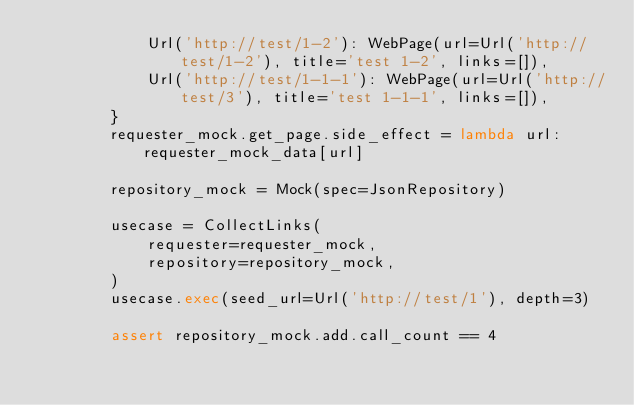Convert code to text. <code><loc_0><loc_0><loc_500><loc_500><_Python_>            Url('http://test/1-2'): WebPage(url=Url('http://test/1-2'), title='test 1-2', links=[]),
            Url('http://test/1-1-1'): WebPage(url=Url('http://test/3'), title='test 1-1-1', links=[]),
        }
        requester_mock.get_page.side_effect = lambda url: requester_mock_data[url]

        repository_mock = Mock(spec=JsonRepository)

        usecase = CollectLinks(
            requester=requester_mock,
            repository=repository_mock,
        )
        usecase.exec(seed_url=Url('http://test/1'), depth=3)

        assert repository_mock.add.call_count == 4
</code> 